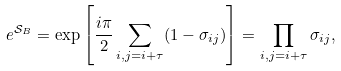<formula> <loc_0><loc_0><loc_500><loc_500>e ^ { \mathcal { S } _ { B } } = \exp { \left [ \frac { i \pi } { 2 } \sum _ { i , j = i + \tau } ( 1 - \sigma _ { i j } ) \right ] } = \prod _ { i , j = i + \tau } \sigma _ { i j } ,</formula> 